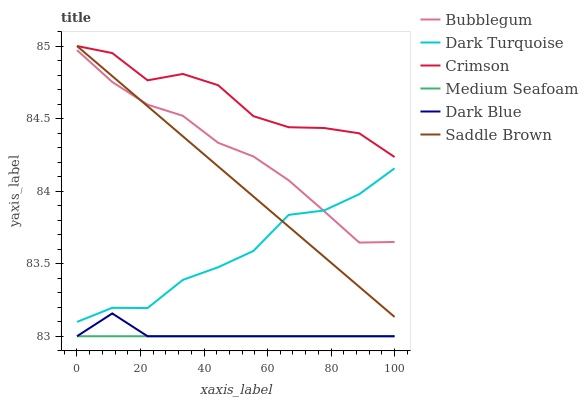Does Medium Seafoam have the minimum area under the curve?
Answer yes or no. Yes. Does Crimson have the maximum area under the curve?
Answer yes or no. Yes. Does Bubblegum have the minimum area under the curve?
Answer yes or no. No. Does Bubblegum have the maximum area under the curve?
Answer yes or no. No. Is Medium Seafoam the smoothest?
Answer yes or no. Yes. Is Crimson the roughest?
Answer yes or no. Yes. Is Bubblegum the smoothest?
Answer yes or no. No. Is Bubblegum the roughest?
Answer yes or no. No. Does Medium Seafoam have the lowest value?
Answer yes or no. Yes. Does Bubblegum have the lowest value?
Answer yes or no. No. Does Saddle Brown have the highest value?
Answer yes or no. Yes. Does Bubblegum have the highest value?
Answer yes or no. No. Is Medium Seafoam less than Saddle Brown?
Answer yes or no. Yes. Is Dark Turquoise greater than Medium Seafoam?
Answer yes or no. Yes. Does Saddle Brown intersect Bubblegum?
Answer yes or no. Yes. Is Saddle Brown less than Bubblegum?
Answer yes or no. No. Is Saddle Brown greater than Bubblegum?
Answer yes or no. No. Does Medium Seafoam intersect Saddle Brown?
Answer yes or no. No. 